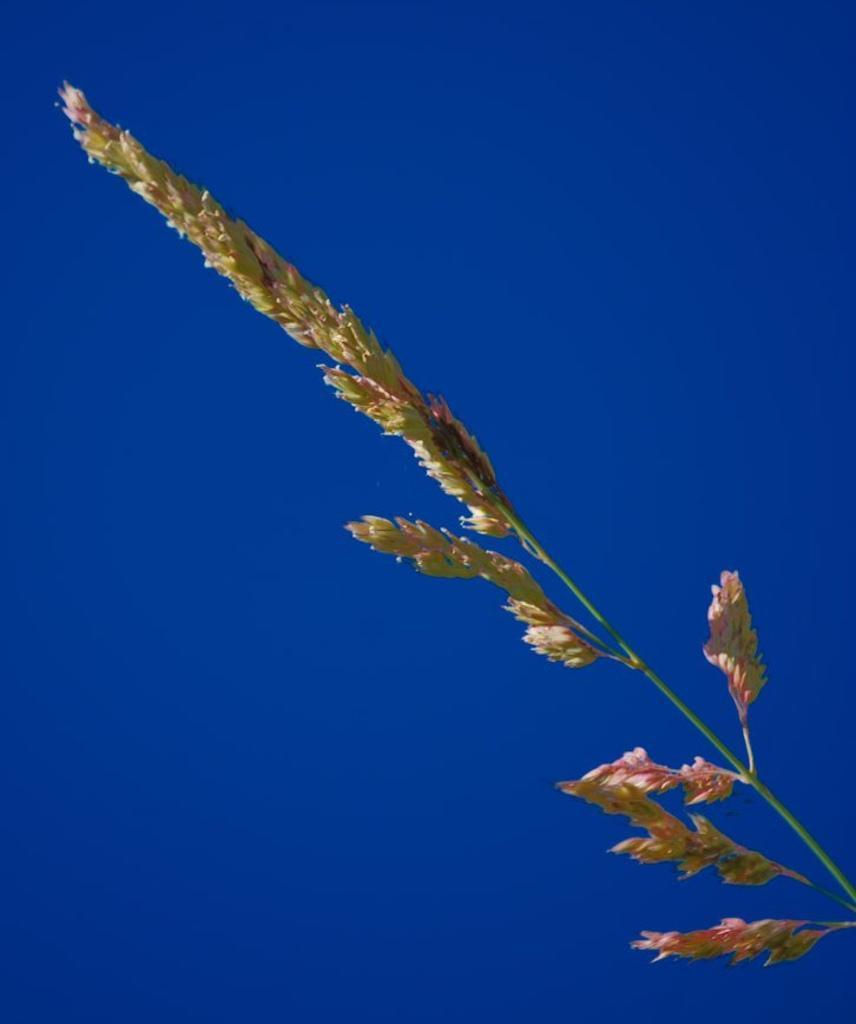Could you give a brief overview of what you see in this image? In this picture we can see the plant. At the top there is a sky. 